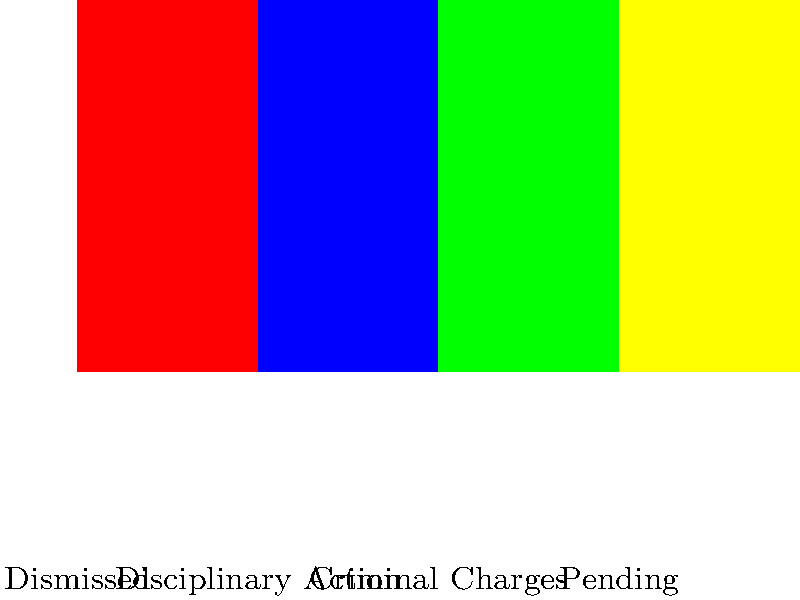Based on the bar graph showing statistics on police misconduct cases and their outcomes, what percentage of cases resulted in criminal charges against the officers involved? To answer this question, we need to analyze the bar graph carefully:

1. The graph shows four categories of outcomes for police misconduct cases: Dismissed, Disciplinary Action, Criminal Charges, and Pending.

2. Each bar represents the percentage of cases falling into each category.

3. We need to locate the bar corresponding to "Criminal Charges."

4. The "Criminal Charges" bar is the third from the left, colored green.

5. By looking at the y-axis, we can see that this bar reaches the 15% mark.

Therefore, the percentage of cases that resulted in criminal charges against the officers involved is 15%.

This information is particularly relevant to your situation as a young man who has just witnessed police misconduct. It shows that while criminal charges are not the most common outcome, they do occur in a significant number of cases, suggesting that reporting misconduct can lead to serious consequences for officers who abuse their power.
Answer: 15% 